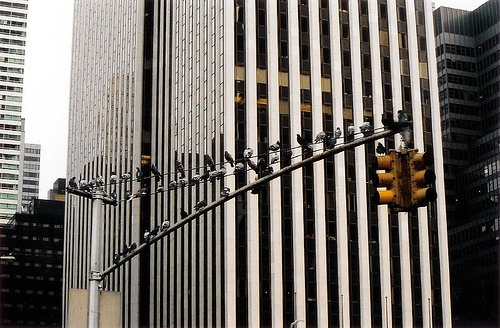Describe the objects in this image and their specific colors. I can see bird in white, black, darkgray, gray, and lightgray tones, traffic light in white, black, maroon, and olive tones, traffic light in white, black, maroon, and olive tones, bird in white, gray, black, darkgray, and lightgray tones, and bird in white, black, ivory, darkgray, and gray tones in this image. 